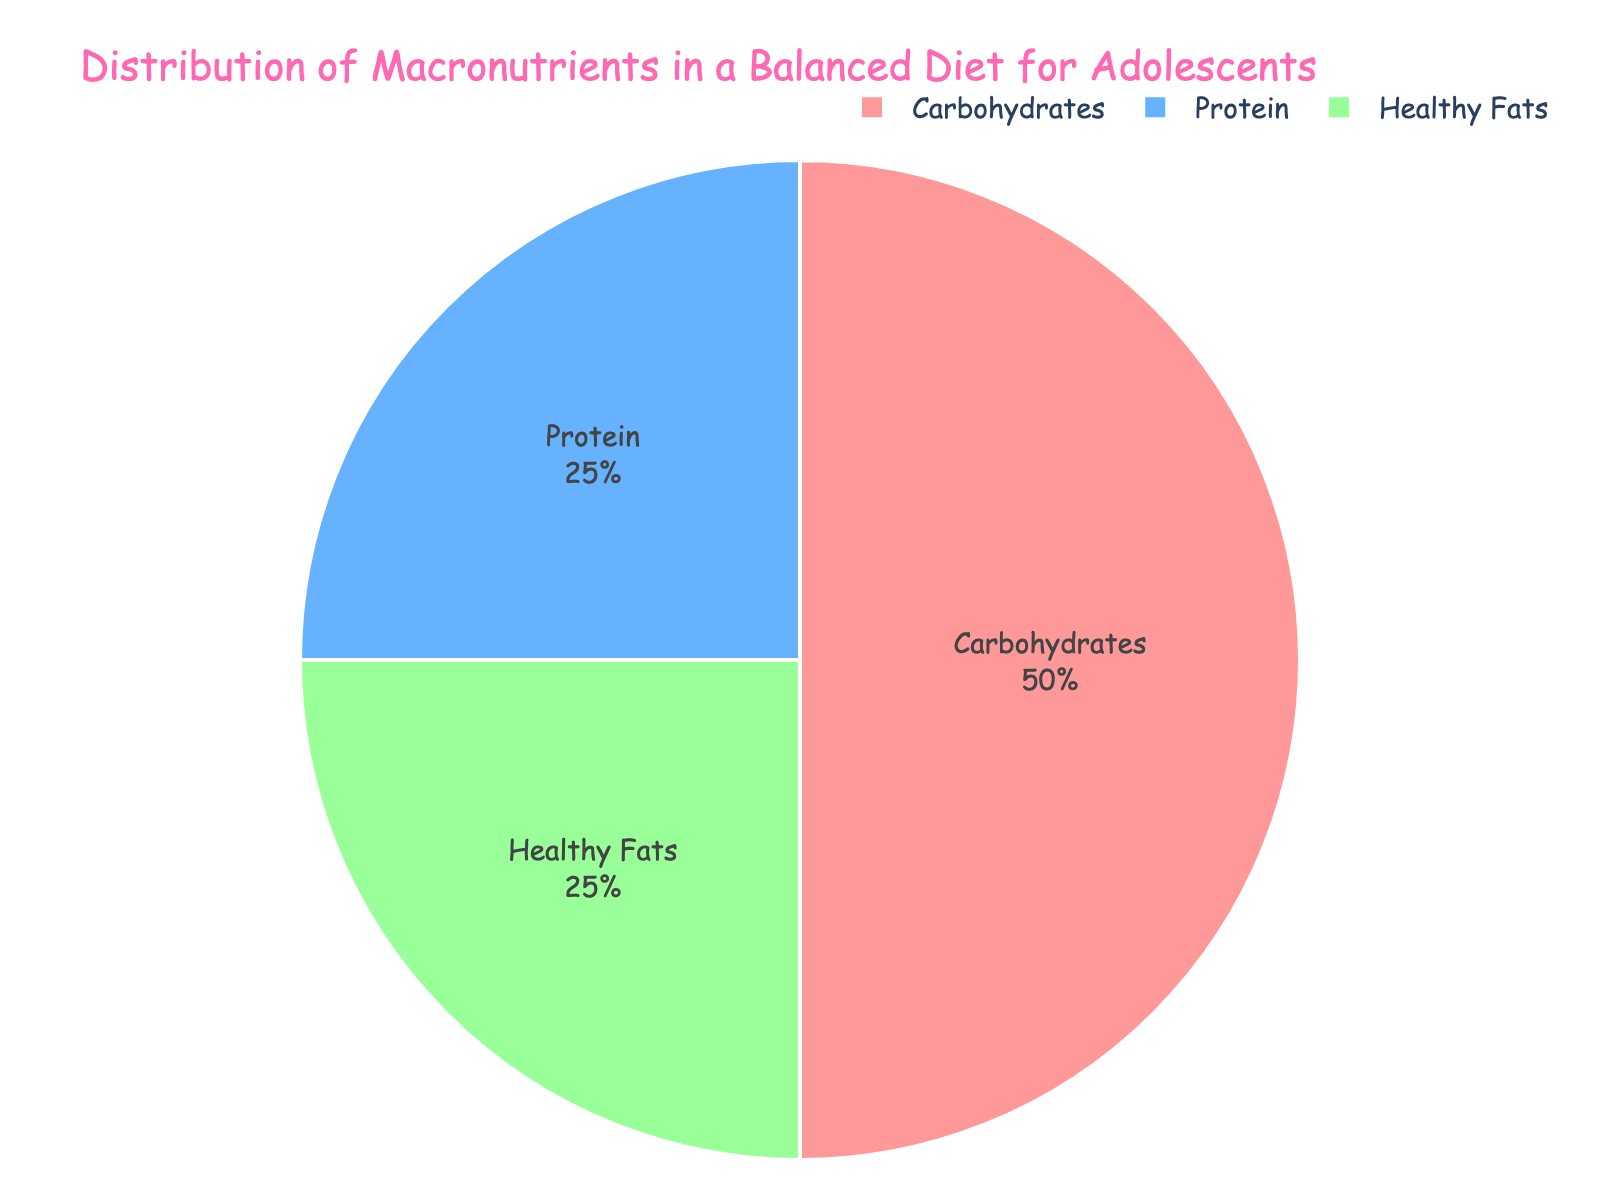What's the percentage of protein in a balanced diet for adolescents? Protein is listed as one of the macronutrients in the pie chart. The percentage indicated for protein is 25%.
Answer: 25% How much more carbohydrates are there compared to protein in the diet? The pie chart shows that carbohydrates are 50% while protein is 25%. The difference between the two is 50% - 25% = 25%.
Answer: 25% Which macronutrient shares the same percentage as proteins? The pie chart shows that both protein and healthy fats have the same percentage of 25%.
Answer: Healthy Fats What percentage of the diet is made up of carbohydrates and healthy fats combined? From the pie chart, carbohydrates make up 50% and healthy fats make up 25%. Combining them gives 50% + 25% = 75%.
Answer: 75% Is the percentage of healthy fats greater than, less than, or equal to the percentage of carbohydrates? The pie chart shows that healthy fats are 25% and carbohydrates are 50%. Since 25% is less than 50%, healthy fats are less than carbohydrates.
Answer: Less than What is the most prominent (largest) macronutrient in the pie chart? The pie chart shows that carbohydrates have the largest percentage at 50%, making them the most prominent macronutrient.
Answer: Carbohydrates By how much do carbohydrates exceed the combined percentage of proteins and healthy fats? Proteins and healthy fats each have 25%, so combined they make up 50%. Carbohydrates also have 50%, so the difference is 50% - 50% = 0%.
Answer: 0% What color represents carbohydrates in the pie chart? The custom color palette shows carbohydrates in a light pink color.
Answer: Light pink 